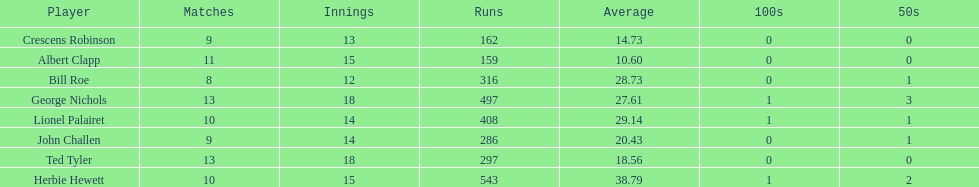How many more runs does john have than albert? 127. 